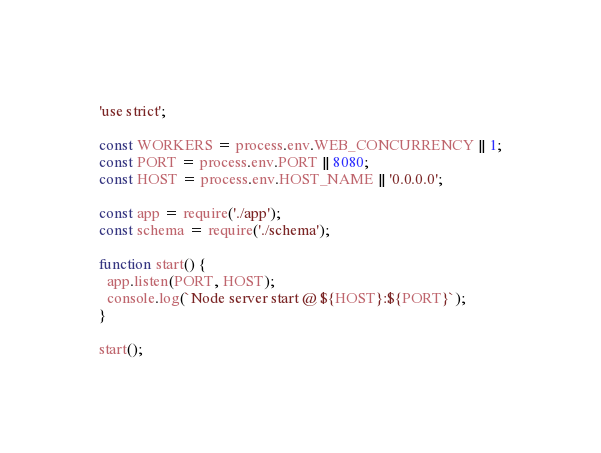Convert code to text. <code><loc_0><loc_0><loc_500><loc_500><_JavaScript_>'use strict';

const WORKERS = process.env.WEB_CONCURRENCY || 1;
const PORT = process.env.PORT || 8080;
const HOST = process.env.HOST_NAME || '0.0.0.0';

const app = require('./app');
const schema = require('./schema');

function start() {
  app.listen(PORT, HOST);
  console.log(`Node server start @ ${HOST}:${PORT}`);
}

start();
</code> 